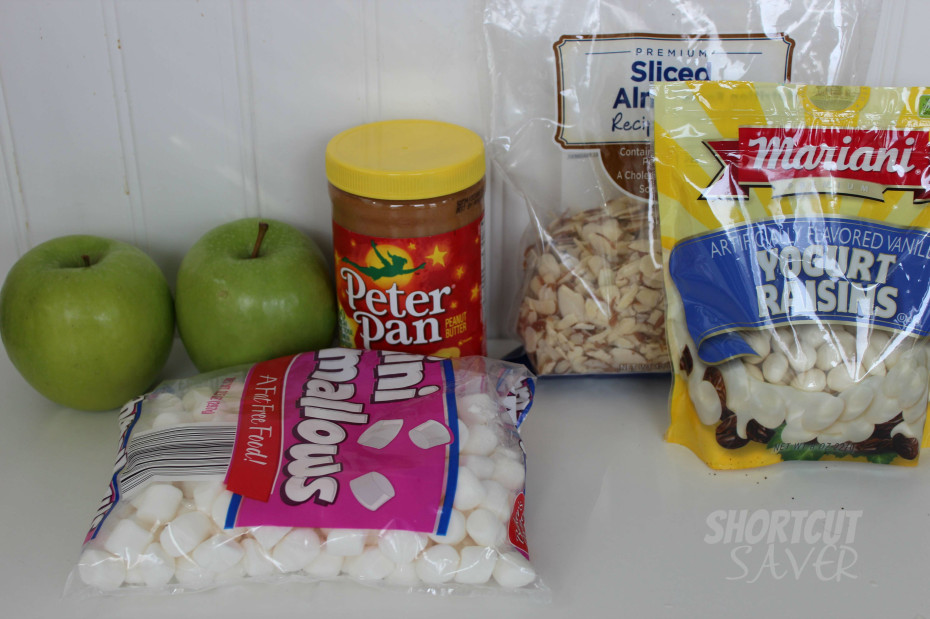Could you suggest a fun cooking activity using these ingredients for kids? A fantastic cooking activity for kids using these ingredients would be making 'Funny Face Dessert Pizzas'. Begin with apple slices as the base. Kids can spread peanut butter on each slice and use marshmallows, sliced almonds, and yogurt-covered raisins to create faces or patterns on their 'pizzas'. This activity not only allows children to be creative but also helps them handle and assemble ingredients, making it a playful educational experience. 